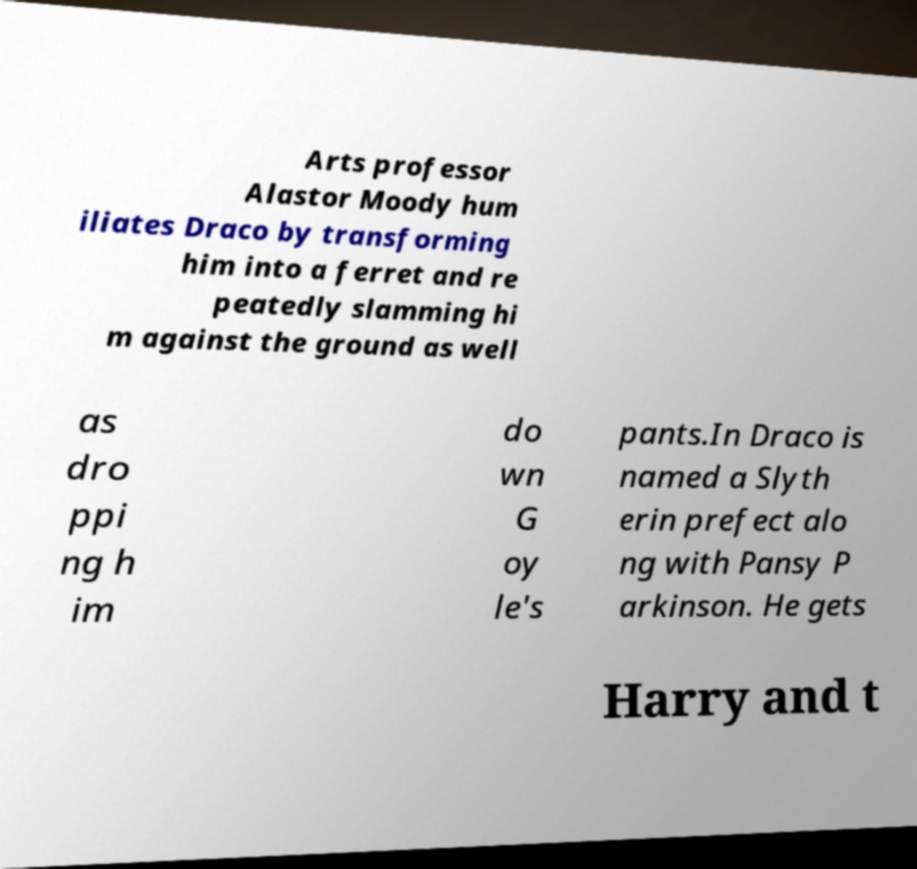For documentation purposes, I need the text within this image transcribed. Could you provide that? Arts professor Alastor Moody hum iliates Draco by transforming him into a ferret and re peatedly slamming hi m against the ground as well as dro ppi ng h im do wn G oy le's pants.In Draco is named a Slyth erin prefect alo ng with Pansy P arkinson. He gets Harry and t 